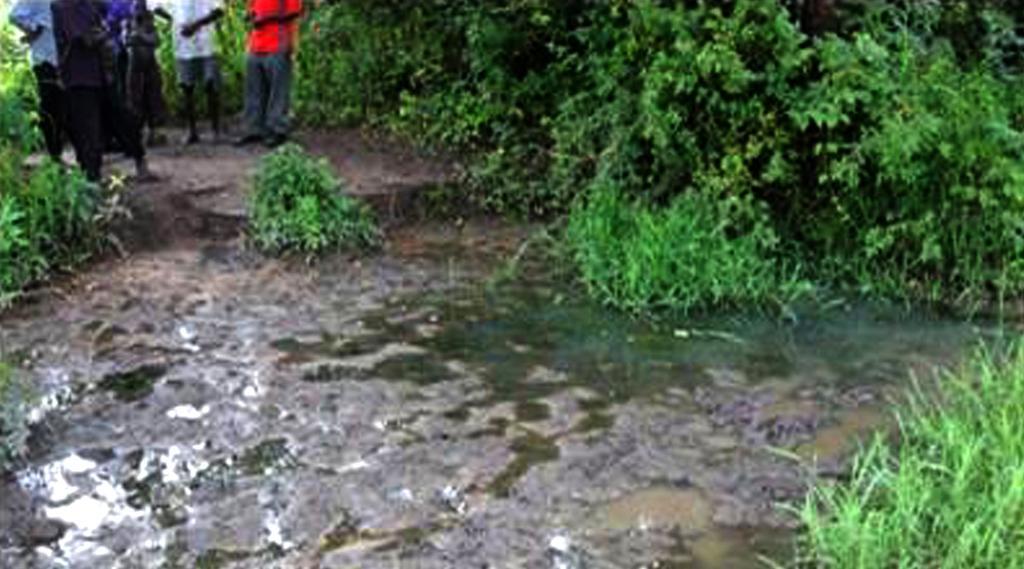Please provide a concise description of this image. On the top left, there are persons standing on the ground. Beside them, there are plants. On the bottom left, there is water. On the right side, there is grass. Beside this grass, there is water. Beside this water, there are plants. 